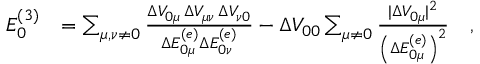Convert formula to latex. <formula><loc_0><loc_0><loc_500><loc_500>\begin{array} { r l } { E _ { 0 } ^ { ( 3 ) } } & { = \sum _ { \mu , \nu \neq 0 } \frac { \Delta V _ { 0 \mu } \, \Delta V _ { \mu \nu } \, \Delta V _ { \nu 0 } } { \Delta E _ { 0 \mu } ^ { ( e ) } \Delta E _ { 0 \nu } ^ { ( e ) } } - \Delta V _ { 0 0 } \sum _ { \mu \neq 0 } \frac { | \Delta V _ { 0 \mu } | ^ { 2 } } { \left ( \Delta E _ { 0 \mu } ^ { ( e ) } \right ) ^ { 2 } } \quad , } \end{array}</formula> 